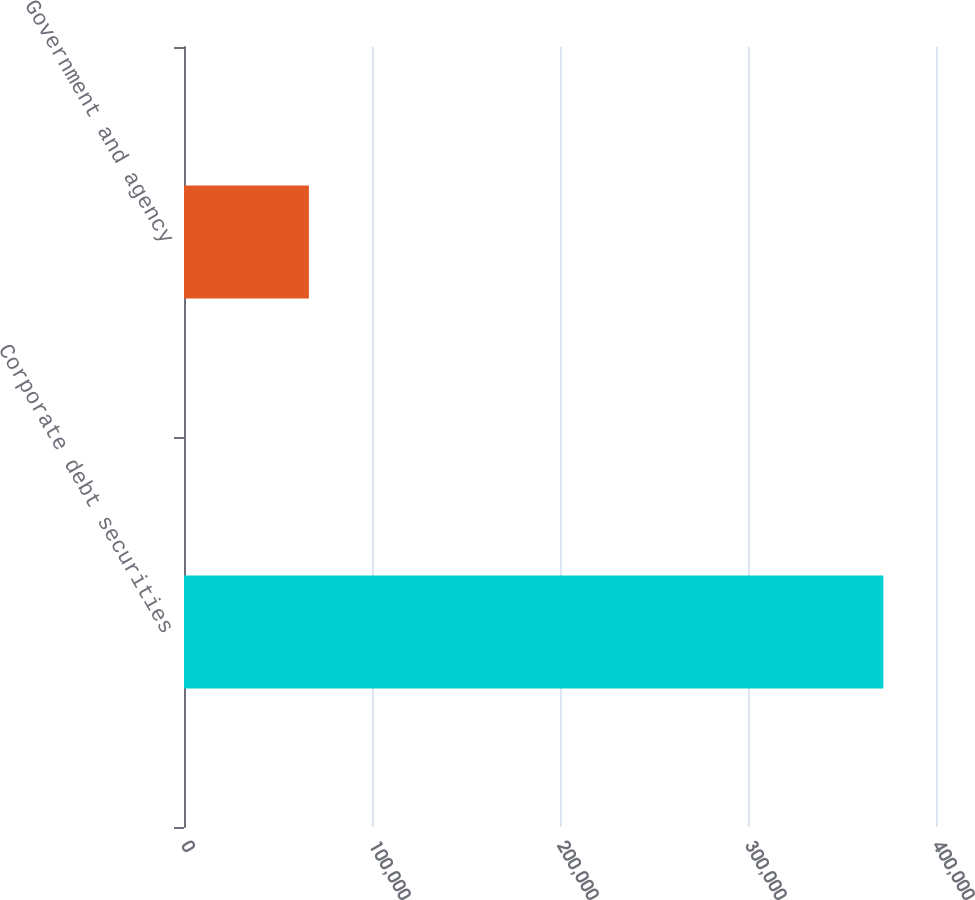Convert chart. <chart><loc_0><loc_0><loc_500><loc_500><bar_chart><fcel>Corporate debt securities<fcel>Government and agency<nl><fcel>371998<fcel>66437<nl></chart> 